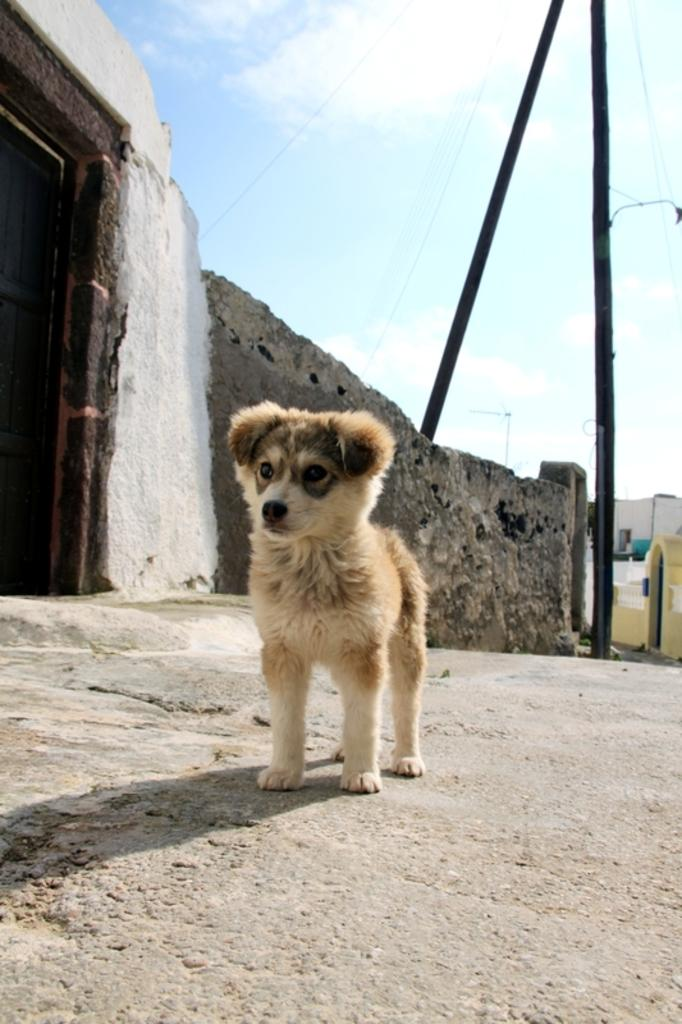What animal can be seen on the road in the image? There is a dog on the road in the image. What type of structure is visible in the image? There is a wall and a house in the image. What architectural feature can be seen in the image? There is a door in the image. What are the vertical structures in the image? There are poles in the image. What can be seen in the background of the image? The sky with clouds is visible in the background of the image. What type of books are being used to cause the dog to levitate in the image? There are no books or levitating dogs present in the image. 